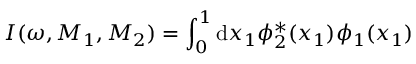<formula> <loc_0><loc_0><loc_500><loc_500>I ( \omega , M _ { 1 } , M _ { 2 } ) = \int _ { 0 } ^ { 1 } d x _ { 1 } \phi _ { 2 } ^ { * } ( x _ { 1 } ) \phi _ { 1 } ( x _ { 1 } )</formula> 